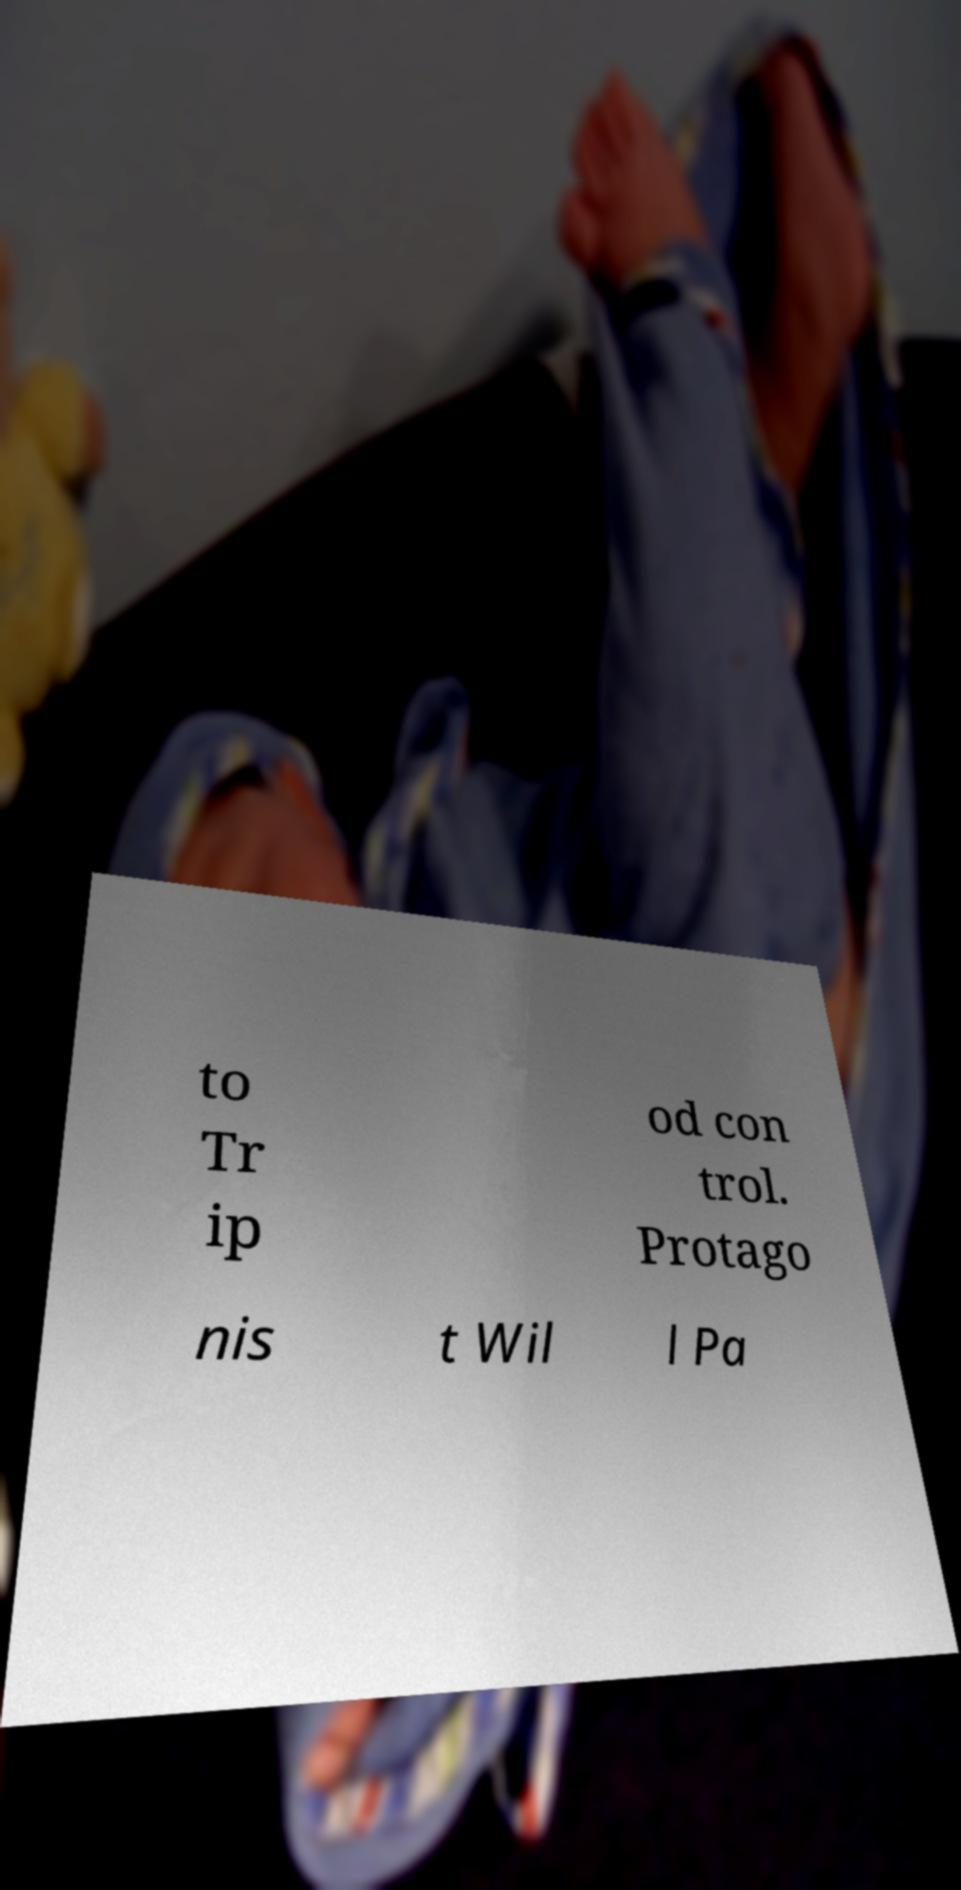There's text embedded in this image that I need extracted. Can you transcribe it verbatim? to Tr ip od con trol. Protago nis t Wil l Pa 